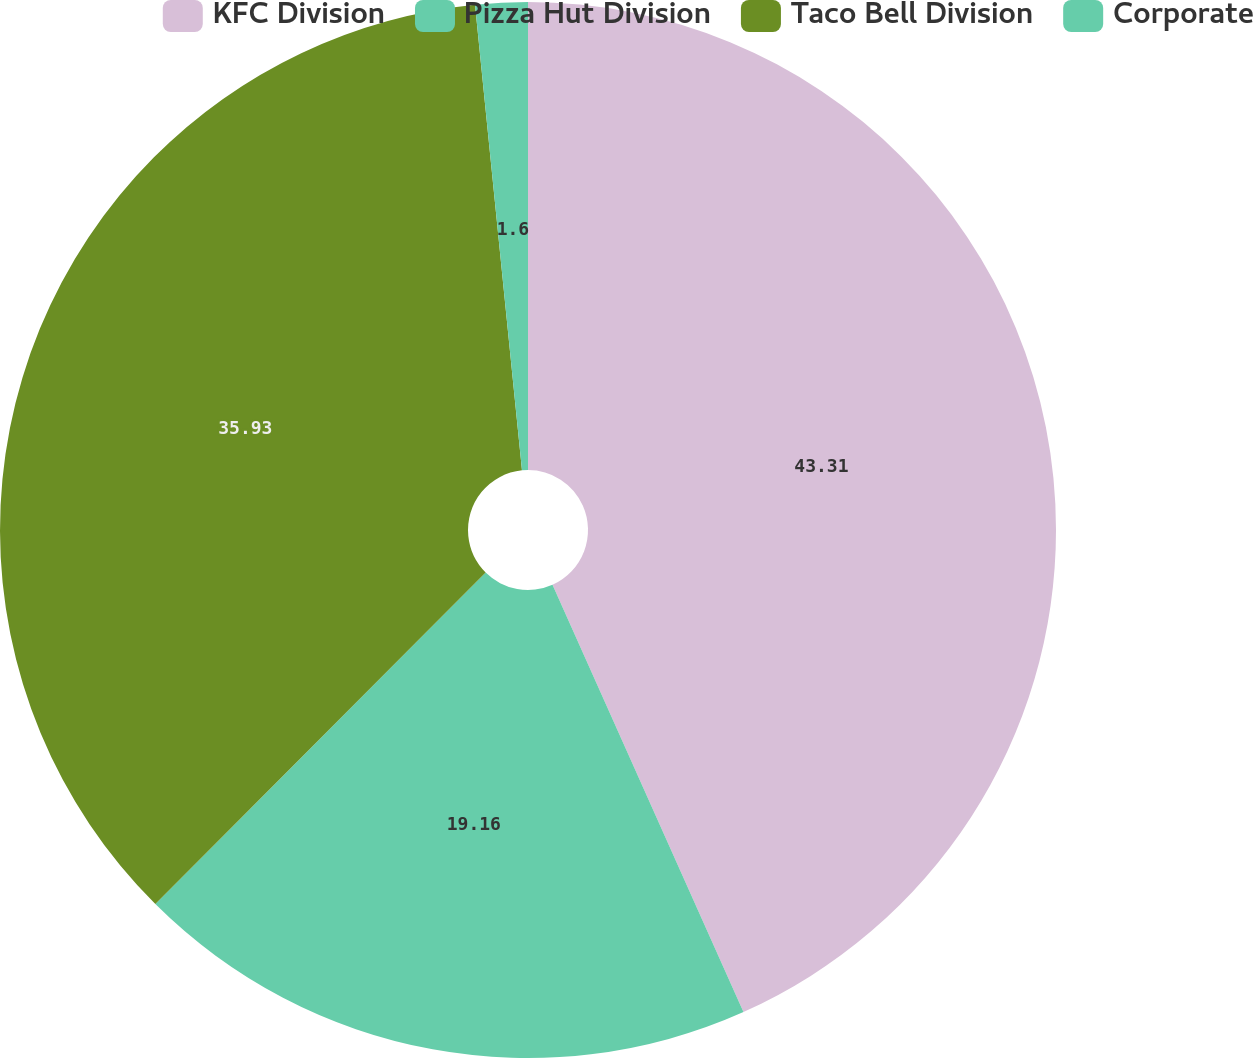Convert chart to OTSL. <chart><loc_0><loc_0><loc_500><loc_500><pie_chart><fcel>KFC Division<fcel>Pizza Hut Division<fcel>Taco Bell Division<fcel>Corporate<nl><fcel>43.31%<fcel>19.16%<fcel>35.93%<fcel>1.6%<nl></chart> 